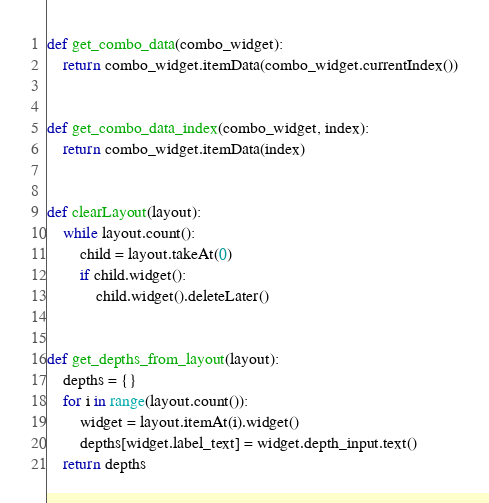<code> <loc_0><loc_0><loc_500><loc_500><_Python_>def get_combo_data(combo_widget):
    return combo_widget.itemData(combo_widget.currentIndex())


def get_combo_data_index(combo_widget, index):
    return combo_widget.itemData(index)


def clearLayout(layout):
    while layout.count():
        child = layout.takeAt(0)
        if child.widget():
            child.widget().deleteLater()


def get_depths_from_layout(layout):
    depths = {}
    for i in range(layout.count()):
        widget = layout.itemAt(i).widget()
        depths[widget.label_text] = widget.depth_input.text()
    return depths
</code> 